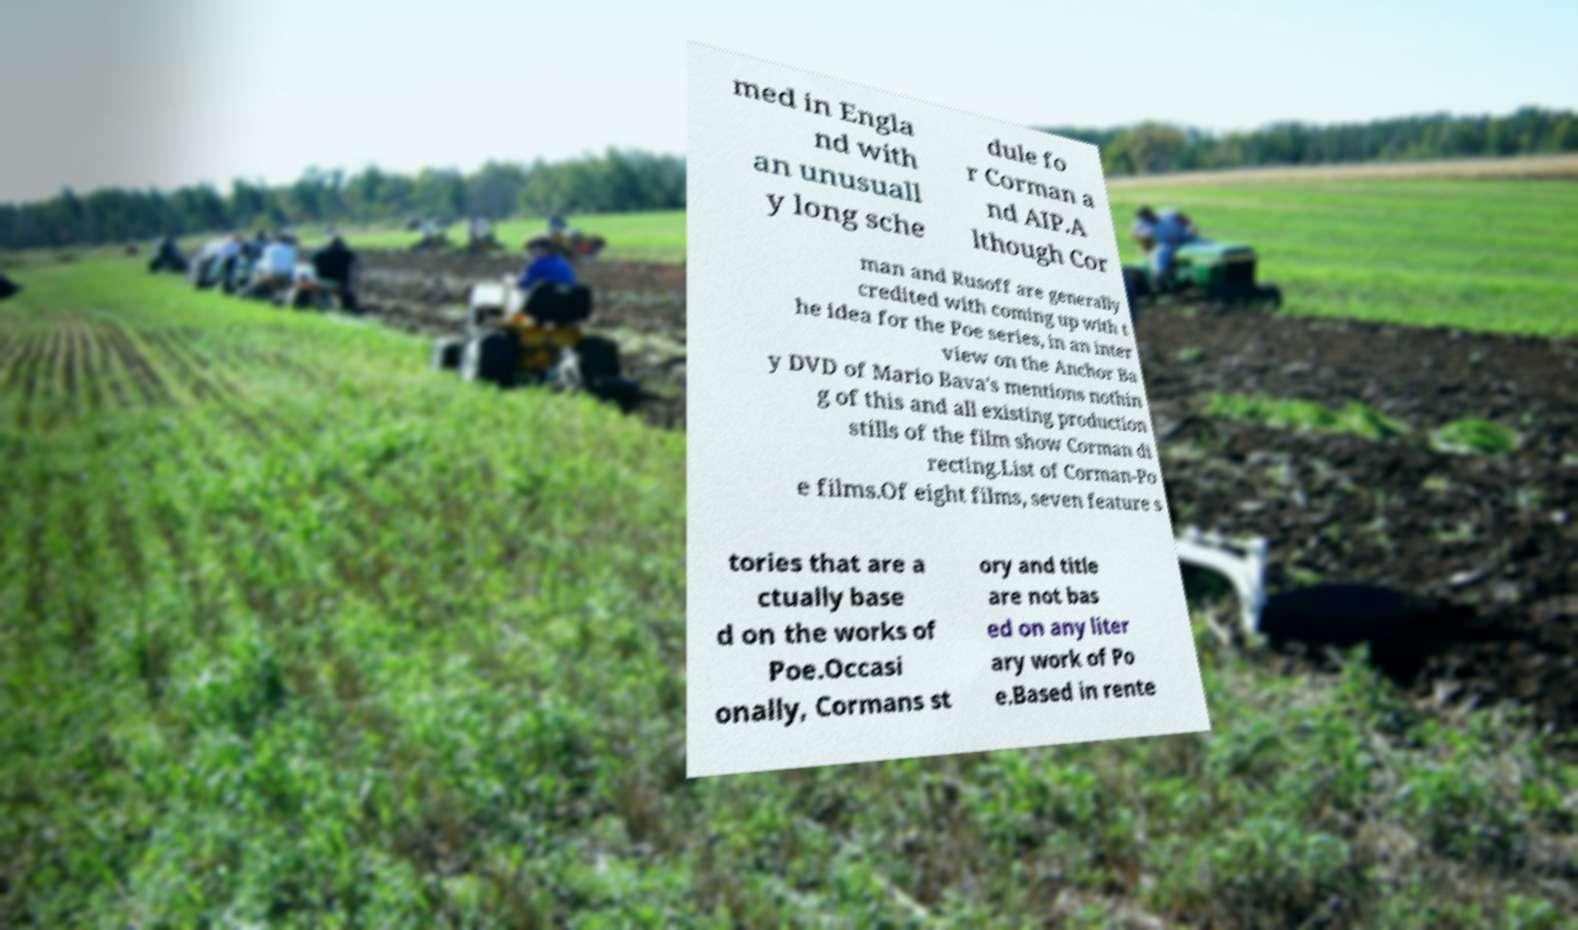Can you accurately transcribe the text from the provided image for me? med in Engla nd with an unusuall y long sche dule fo r Corman a nd AIP.A lthough Cor man and Rusoff are generally credited with coming up with t he idea for the Poe series, in an inter view on the Anchor Ba y DVD of Mario Bava's mentions nothin g of this and all existing production stills of the film show Corman di recting.List of Corman-Po e films.Of eight films, seven feature s tories that are a ctually base d on the works of Poe.Occasi onally, Cormans st ory and title are not bas ed on any liter ary work of Po e.Based in rente 